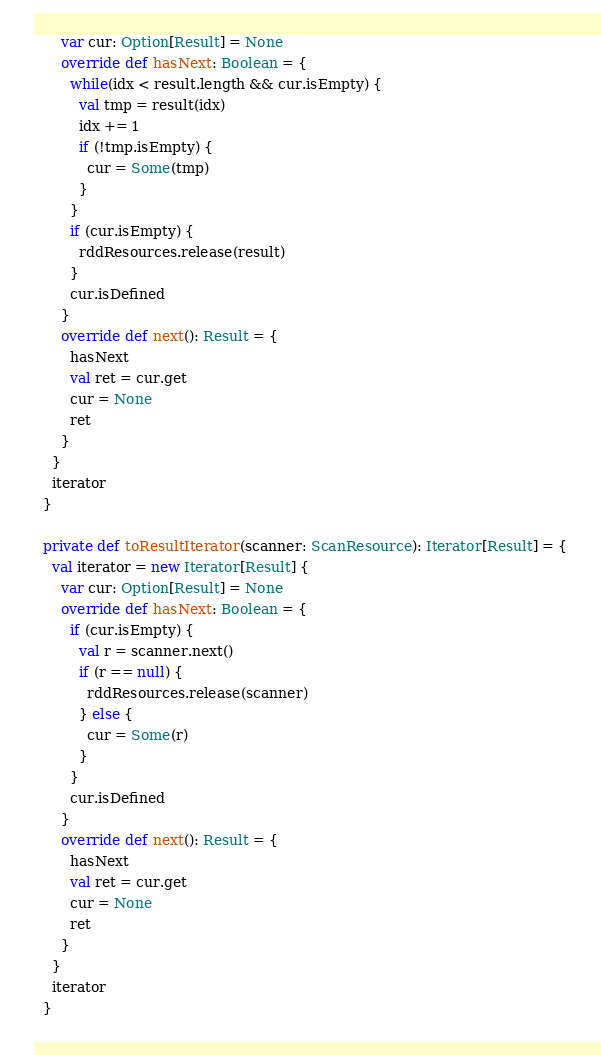Convert code to text. <code><loc_0><loc_0><loc_500><loc_500><_Scala_>      var cur: Option[Result] = None
      override def hasNext: Boolean = {
        while(idx < result.length && cur.isEmpty) {
          val tmp = result(idx)
          idx += 1
          if (!tmp.isEmpty) {
            cur = Some(tmp)
          }
        }
        if (cur.isEmpty) {
          rddResources.release(result)
        }
        cur.isDefined
      }
      override def next(): Result = {
        hasNext
        val ret = cur.get
        cur = None
        ret
      }
    }
    iterator
  }

  private def toResultIterator(scanner: ScanResource): Iterator[Result] = {
    val iterator = new Iterator[Result] {
      var cur: Option[Result] = None
      override def hasNext: Boolean = {
        if (cur.isEmpty) {
          val r = scanner.next()
          if (r == null) {
            rddResources.release(scanner)
          } else {
            cur = Some(r)
          }
        }
        cur.isDefined
      }
      override def next(): Result = {
        hasNext
        val ret = cur.get
        cur = None
        ret
      }
    }
    iterator
  }
</code> 